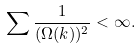Convert formula to latex. <formula><loc_0><loc_0><loc_500><loc_500>\sum \frac { 1 } { ( \Omega ( k ) ) ^ { 2 } } < \infty .</formula> 